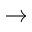Convert formula to latex. <formula><loc_0><loc_0><loc_500><loc_500>\rightarrow</formula> 